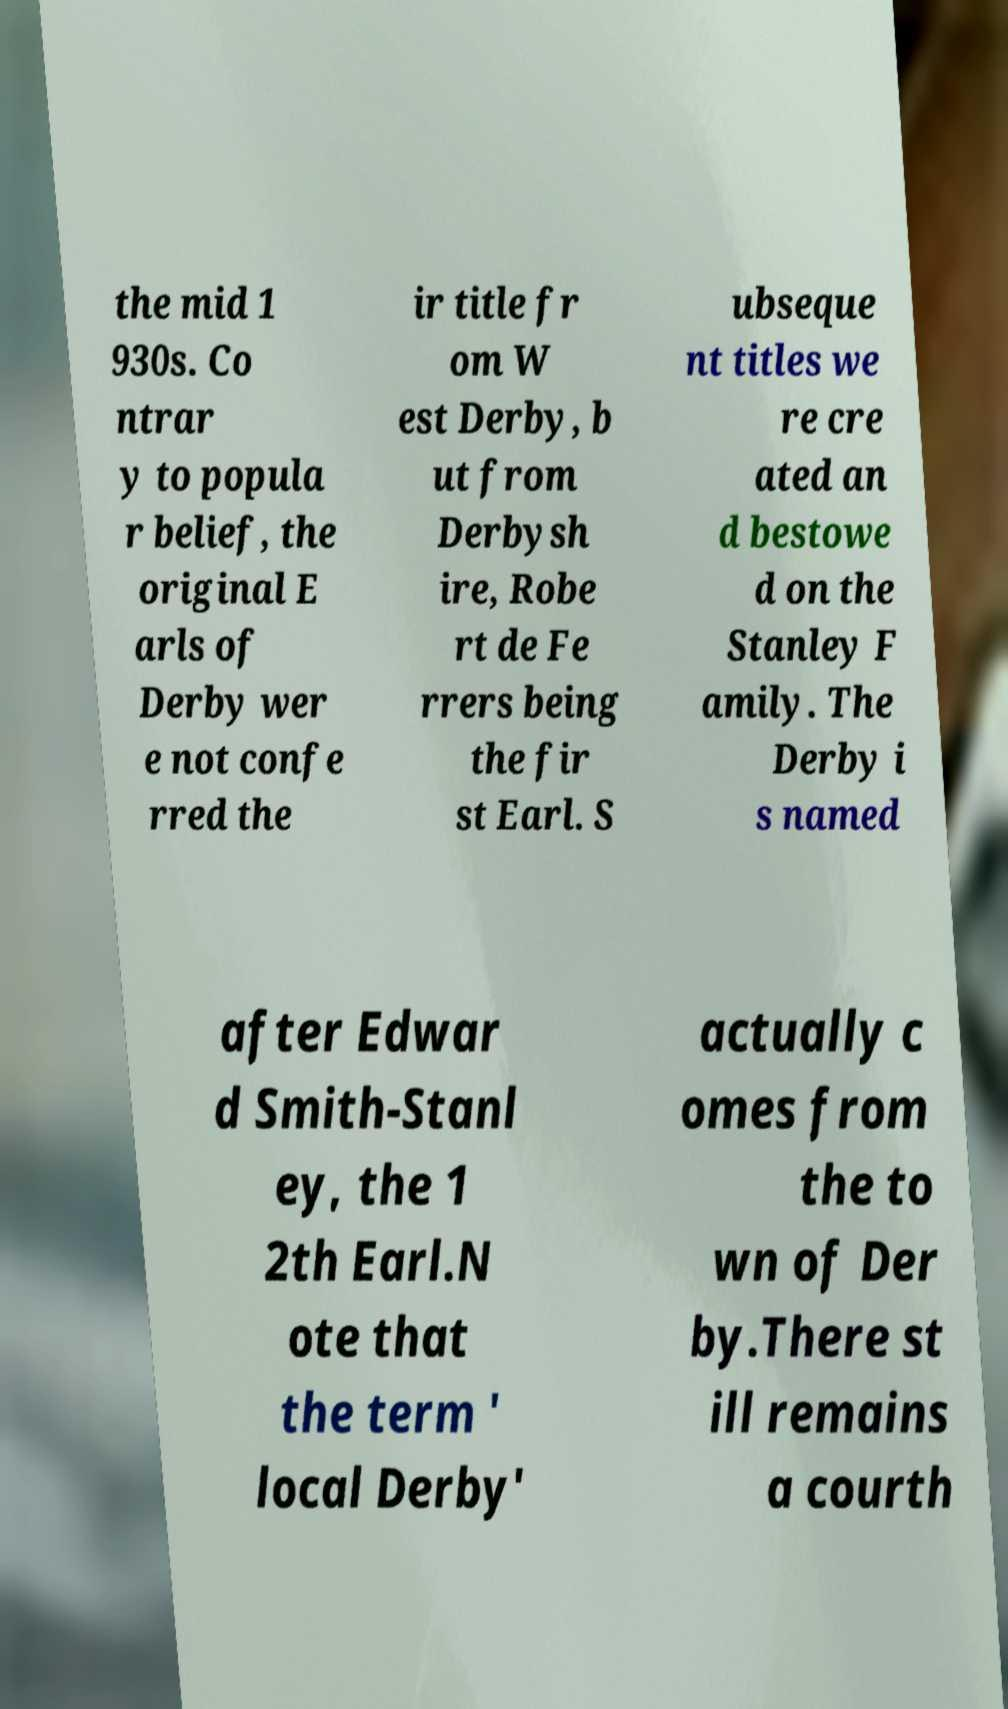Can you accurately transcribe the text from the provided image for me? the mid 1 930s. Co ntrar y to popula r belief, the original E arls of Derby wer e not confe rred the ir title fr om W est Derby, b ut from Derbysh ire, Robe rt de Fe rrers being the fir st Earl. S ubseque nt titles we re cre ated an d bestowe d on the Stanley F amily. The Derby i s named after Edwar d Smith-Stanl ey, the 1 2th Earl.N ote that the term ' local Derby' actually c omes from the to wn of Der by.There st ill remains a courth 